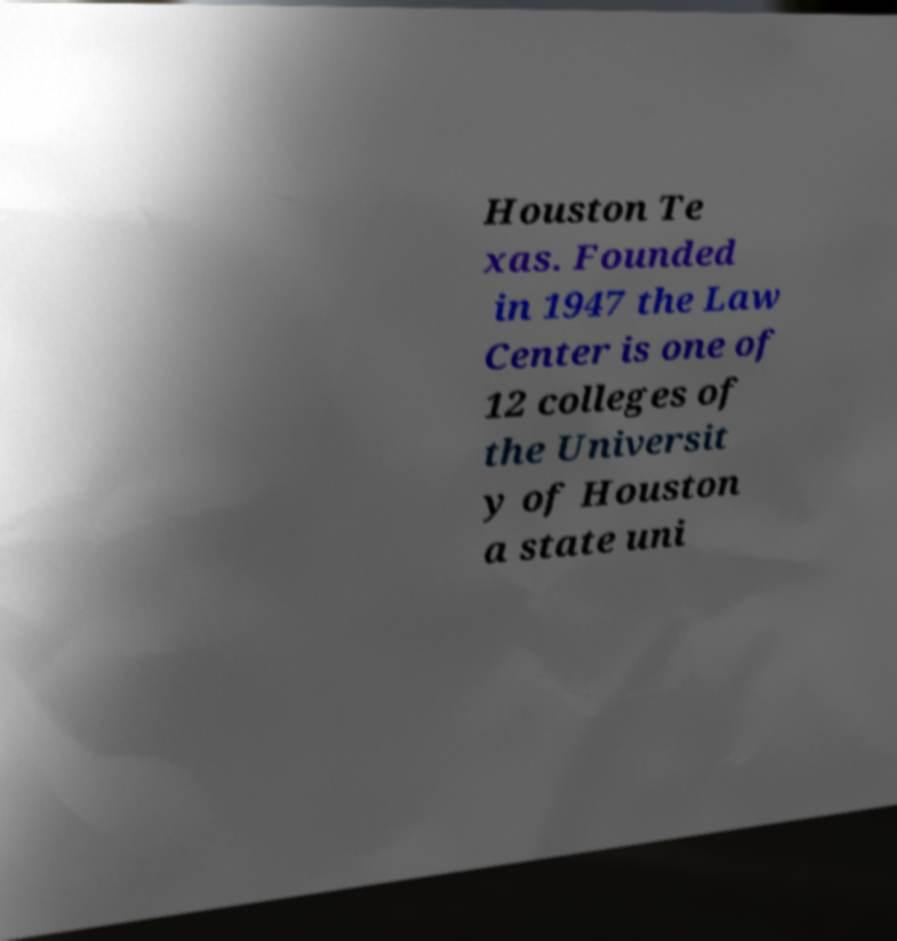I need the written content from this picture converted into text. Can you do that? Houston Te xas. Founded in 1947 the Law Center is one of 12 colleges of the Universit y of Houston a state uni 